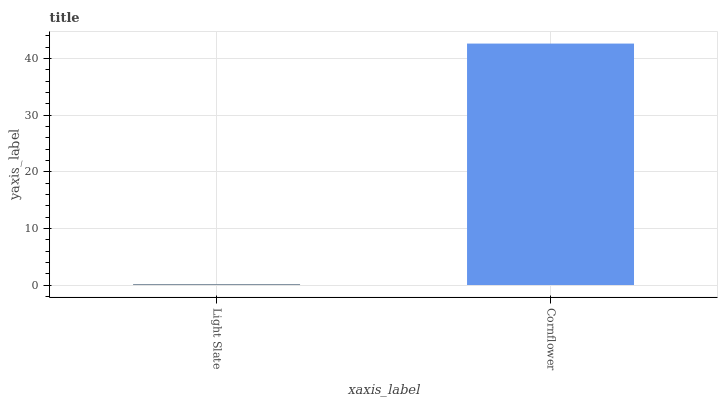Is Light Slate the minimum?
Answer yes or no. Yes. Is Cornflower the maximum?
Answer yes or no. Yes. Is Cornflower the minimum?
Answer yes or no. No. Is Cornflower greater than Light Slate?
Answer yes or no. Yes. Is Light Slate less than Cornflower?
Answer yes or no. Yes. Is Light Slate greater than Cornflower?
Answer yes or no. No. Is Cornflower less than Light Slate?
Answer yes or no. No. Is Cornflower the high median?
Answer yes or no. Yes. Is Light Slate the low median?
Answer yes or no. Yes. Is Light Slate the high median?
Answer yes or no. No. Is Cornflower the low median?
Answer yes or no. No. 